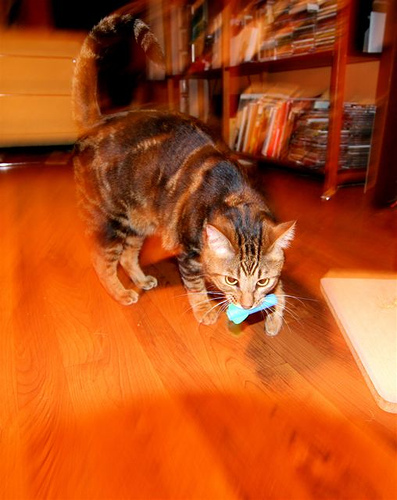<image>
Is the book on the floor? No. The book is not positioned on the floor. They may be near each other, but the book is not supported by or resting on top of the floor. Is there a cat in front of the toy? No. The cat is not in front of the toy. The spatial positioning shows a different relationship between these objects. 